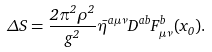<formula> <loc_0><loc_0><loc_500><loc_500>\Delta S = \frac { 2 \pi ^ { 2 } \rho ^ { 2 } } { g ^ { 2 } } \bar { \eta } ^ { a \mu \nu } D ^ { a b } F ^ { b } _ { \mu \nu } ( x _ { 0 } ) .</formula> 